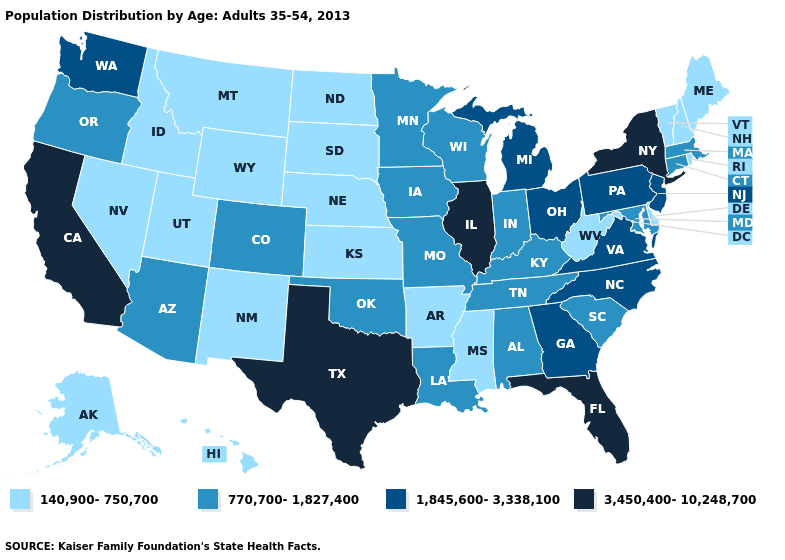Name the states that have a value in the range 1,845,600-3,338,100?
Give a very brief answer. Georgia, Michigan, New Jersey, North Carolina, Ohio, Pennsylvania, Virginia, Washington. Name the states that have a value in the range 3,450,400-10,248,700?
Keep it brief. California, Florida, Illinois, New York, Texas. Which states have the highest value in the USA?
Give a very brief answer. California, Florida, Illinois, New York, Texas. What is the lowest value in the USA?
Write a very short answer. 140,900-750,700. What is the value of Illinois?
Write a very short answer. 3,450,400-10,248,700. What is the value of Washington?
Quick response, please. 1,845,600-3,338,100. What is the value of Nebraska?
Give a very brief answer. 140,900-750,700. Name the states that have a value in the range 770,700-1,827,400?
Be succinct. Alabama, Arizona, Colorado, Connecticut, Indiana, Iowa, Kentucky, Louisiana, Maryland, Massachusetts, Minnesota, Missouri, Oklahoma, Oregon, South Carolina, Tennessee, Wisconsin. Does California have the highest value in the USA?
Give a very brief answer. Yes. What is the value of Virginia?
Be succinct. 1,845,600-3,338,100. What is the value of Connecticut?
Answer briefly. 770,700-1,827,400. Which states have the highest value in the USA?
Give a very brief answer. California, Florida, Illinois, New York, Texas. What is the value of Oregon?
Give a very brief answer. 770,700-1,827,400. Name the states that have a value in the range 770,700-1,827,400?
Concise answer only. Alabama, Arizona, Colorado, Connecticut, Indiana, Iowa, Kentucky, Louisiana, Maryland, Massachusetts, Minnesota, Missouri, Oklahoma, Oregon, South Carolina, Tennessee, Wisconsin. Among the states that border Tennessee , does Missouri have the highest value?
Quick response, please. No. 